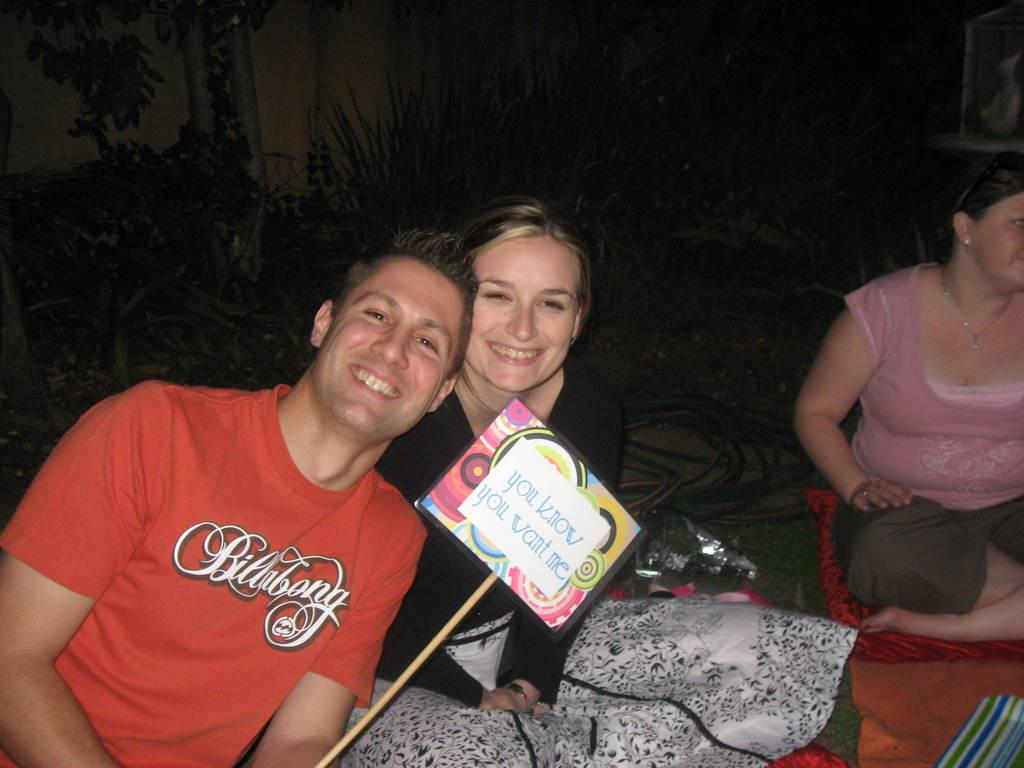How many people are in the image? There are three persons in the image. What is the person wearing a red shirt doing? The person in the red shirt is holding a board. Can you describe the board? The board has multiple colors. What is the color of the background in the image? The background of the image is dark. What type of noise is being made by the spoon in the image? There is no spoon present in the image, so it cannot be making any noise. Can you tell me how many cards are being held by the person in the red shirt? The person in the red shirt is holding a board, not a card, so it is not possible to determine the number of cards. 